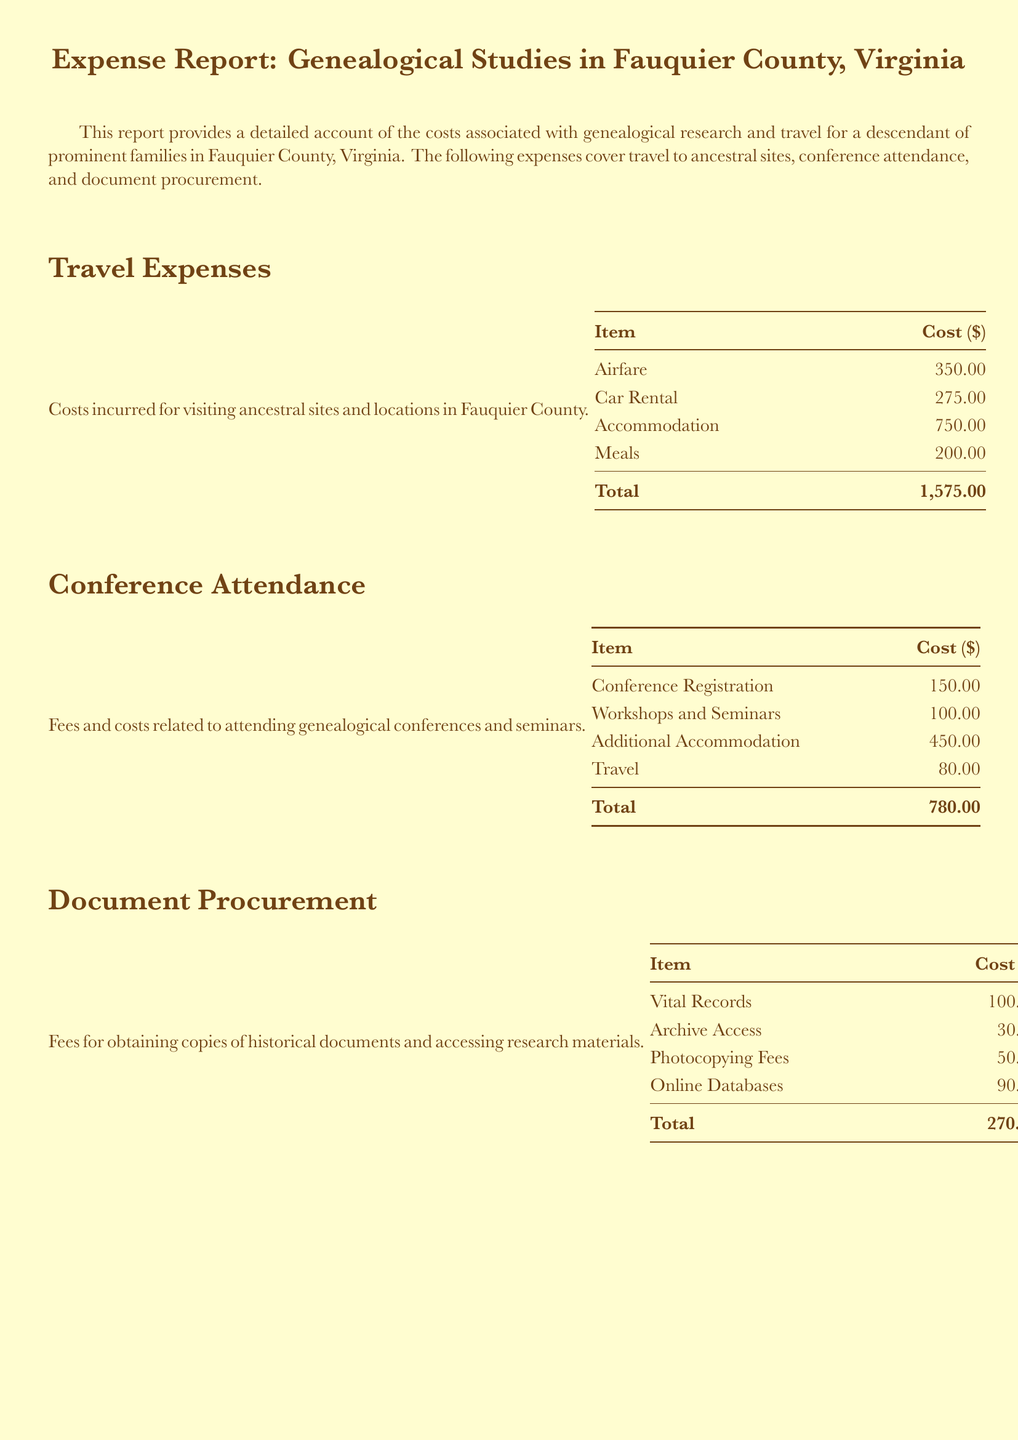What is the total travel expense? The total travel expense is provided in the section titled "Travel Expenses," which details the costs related to visiting ancestral sites.
Answer: 1,575.00 How much was spent on conference registration? The specific cost for conference registration is listed under the "Conference Attendance" section.
Answer: 150.00 What is the total cost for document procurement? The total cost for document procurement is found in the section about accessing research materials and obtaining historical documents.
Answer: 270.00 What is the grand total of all expenses? The grand total is the sum of all the categories listed in the report and is provided in the final section.
Answer: 2,625.00 How much was spent on additional accommodation for conferences? The amount spent on additional accommodation during conference attendance is presented in the "Conference Attendance" details.
Answer: 450.00 What is the cost of photocopying fees? The photocopying fees are specified in the "Document Procurement" section of the report.
Answer: 50.00 How many categories of expenses are detailed in the report? The report includes three distinct categories related to genealogical studies expenses.
Answer: Three What is the cost of meals during travel? The specific expenditure on meals incurred during travel is outlined in the "Travel Expenses" section.
Answer: 200.00 What type of expenses does the document cover? The document provides an account of expenses related to travel, conference attendance, and document procurement.
Answer: Genealogical studies 